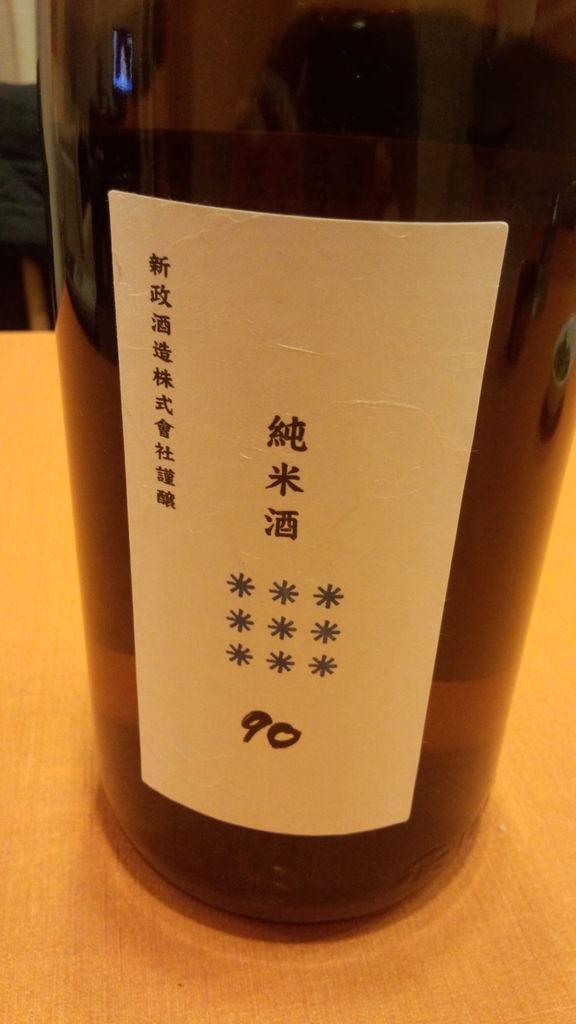In one or two sentences, can you explain what this image depicts? In this image there is bottle kept on the table. There is a sticker on the bottle and it is written as Nine Zero, Ninety. 